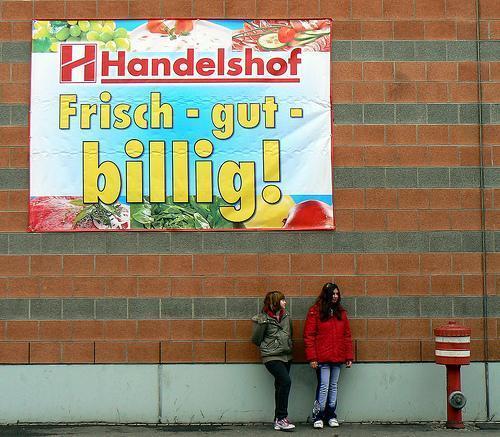How many people in picture?
Give a very brief answer. 2. How many peaple wears red coats in the image?
Give a very brief answer. 1. 